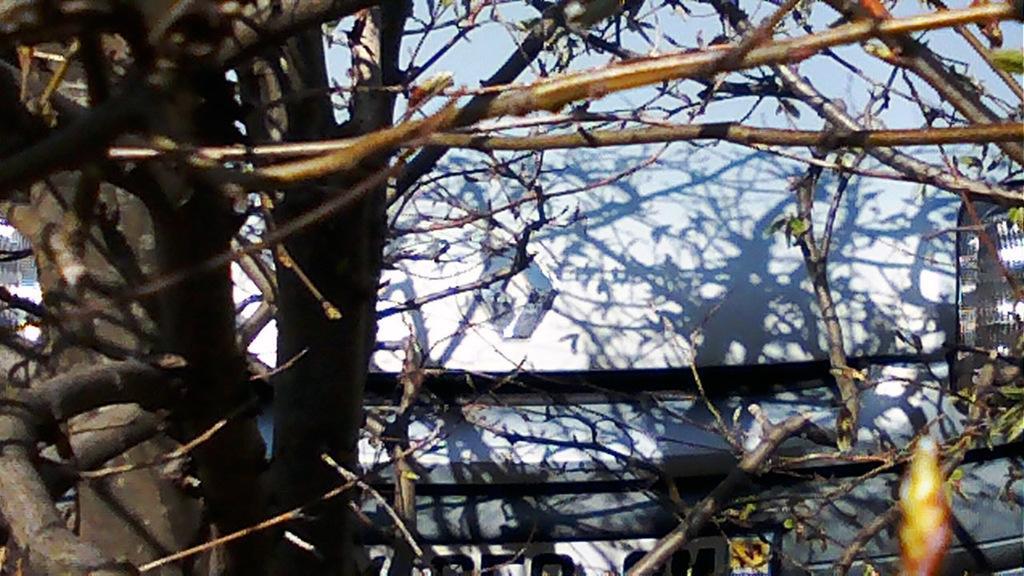Please provide a concise description of this image. In this image we can see a tree without leaves and a wall. 